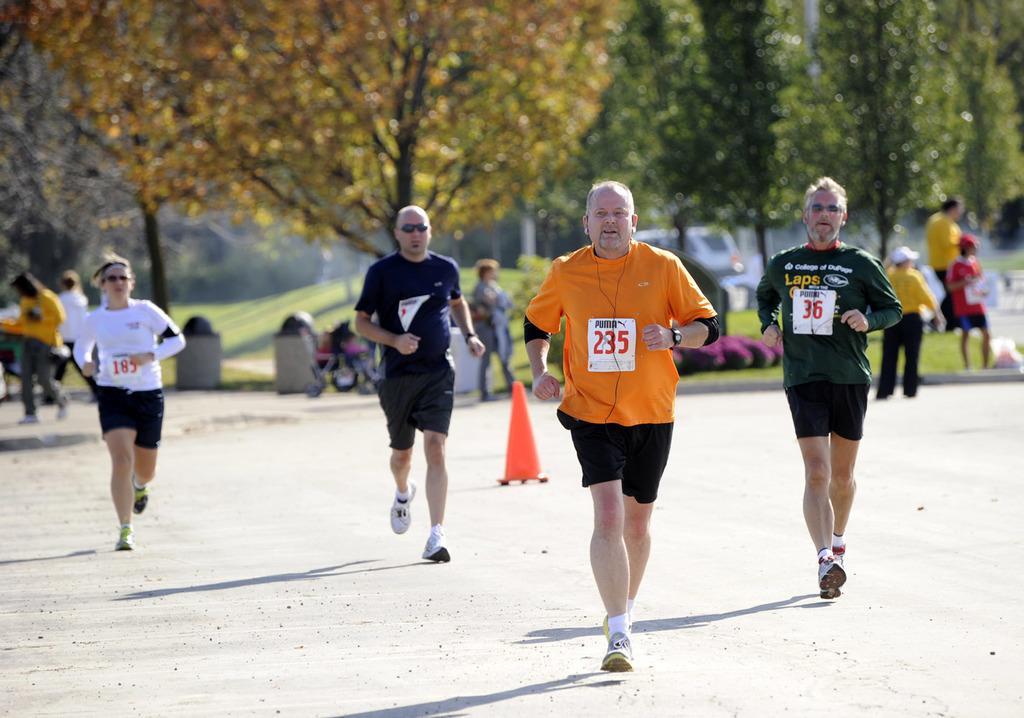Describe this image in one or two sentences. In this image, we can see persons wearing clothes and running on the road. There is a divider cone in the middle of the image. In the background of the image, we can see some persons and trees. 